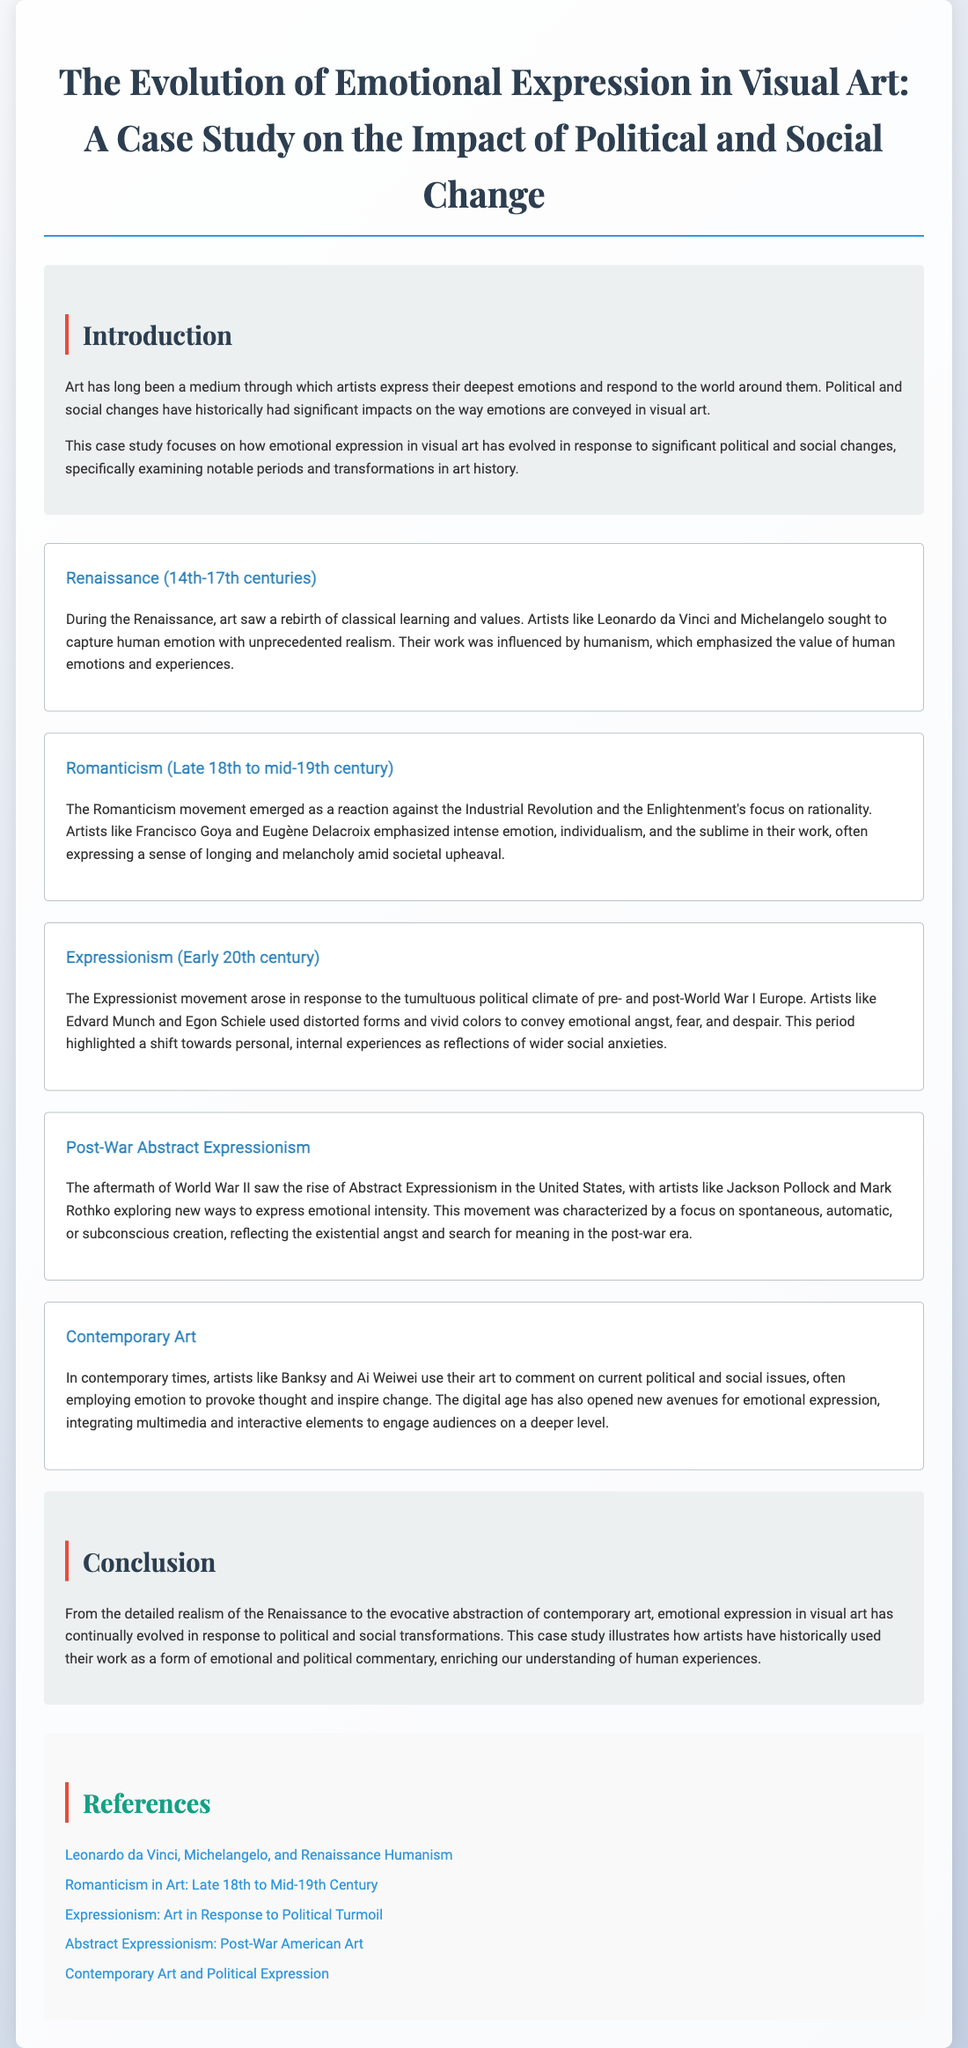What was the main focus of the case study? The case study focuses on how emotional expression in visual art has evolved in response to significant political and social changes.
Answer: Emotional expression evolution Who are two prominent artists from the Renaissance period? Artists like Leonardo da Vinci and Michelangelo are notable figures from the Renaissance period.
Answer: Leonardo da Vinci and Michelangelo What movement emphasized intense emotion and individualism? The Romanticism movement emphasized intense emotion and individualism.
Answer: Romanticism What characterizes Post-War Abstract Expressionism? The movement is characterized by a focus on spontaneous, automatic, or subconscious creation.
Answer: Spontaneous creation Which contemporary artists are mentioned in relation to political issues? Artists like Banksy and Ai Weiwei use their art to comment on current political and social issues.
Answer: Banksy and Ai Weiwei What notable emotional expressions are associated with Expressionism? Expressionism is associated with emotional angst, fear, and despair.
Answer: Angst, fear, and despair During which century did the Romanticism movement occur? The Romanticism movement occurred from the late 18th to mid-19th century.
Answer: Late 18th to mid-19th century What do Edvard Munch and Egon Schiele represent in art history? They represent the Expressionist movement in art history.
Answer: Expressionism What is the primary theme of the conclusion? The primary theme of the conclusion is the evolution of emotional expression in visual art in response to political and social transformations.
Answer: Evolution of emotional expression 